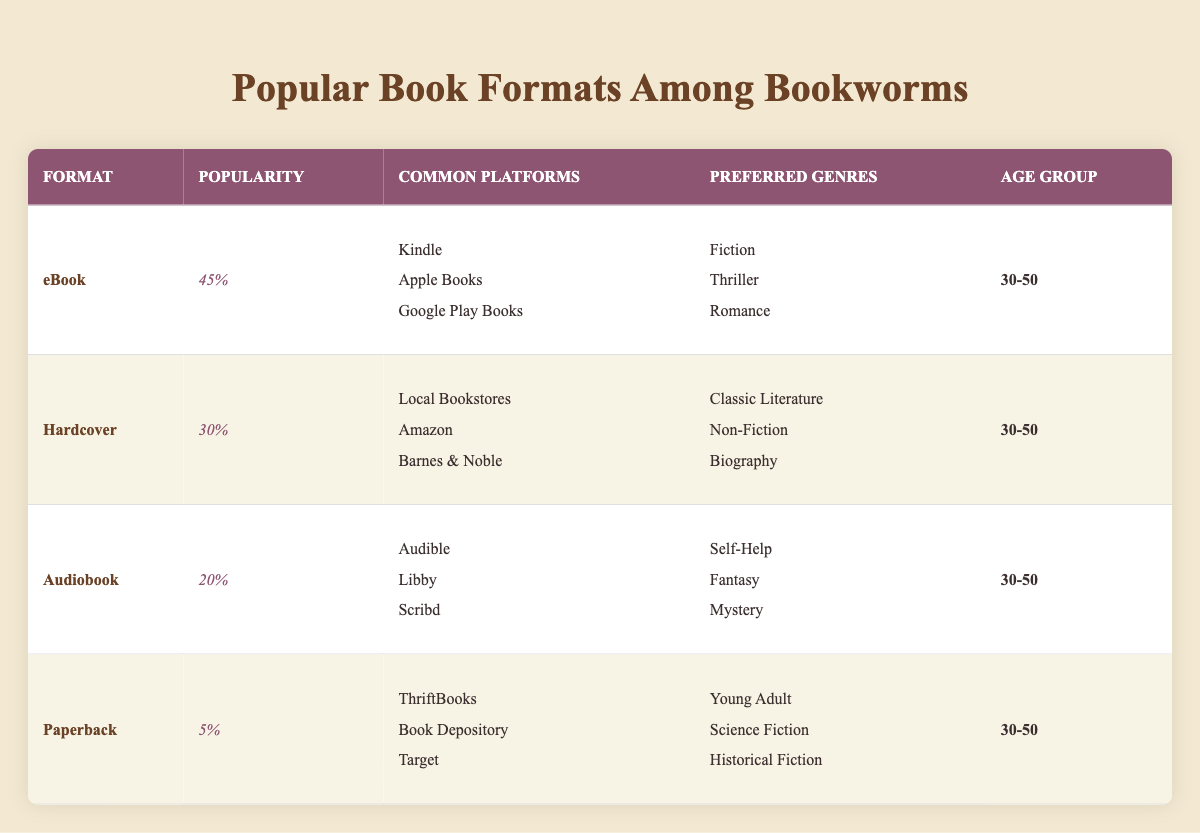What format has the highest popularity percentage? The table indicates that the eBook format has a popularity percentage of 45%, which is higher than any other format listed.
Answer: eBook What are the common platforms for reading Audiobooks? According to the table, the common platforms for Audiobooks include Audible, Libby, and Scribd.
Answer: Audible, Libby, Scribd Is the Paperback format more popular than the Hardcover format? The popularity percentage for Paperback is 5%, while for Hardcover it is 30%. Therefore, Paperback is not more popular than Hardcover.
Answer: No What is the combined popularity percentage of eBooks and Hardcovers? To find the combined popularity, we add the popularity percentages of eBooks (45%) and Hardcovers (30%), resulting in 45 + 30 = 75%.
Answer: 75% Which preferred genre is associated with the eBook format? The table shows that the preferred genres for eBooks include Fiction, Thriller, and Romance.
Answer: Fiction, Thriller, Romance Does Audiobook have more common platforms than Paperback? The Audiobook format lists three common platforms (Audible, Libby, Scribd) whereas the Paperback format also lists three platforms (ThriftBooks, Book Depository, Target). Thus, they have the same number of platforms.
Answer: No What age group is most represented across all book formats? The table indicates that all formats mentioned (eBook, Hardcover, Audiobook, and Paperback) are popular among the age group 30-50.
Answer: 30-50 What is the least popular book format and what is its percentage? The Paperback format has the least popularity percentage at 5%, which is lower than all the other formats in the table.
Answer: Paperback, 5% 